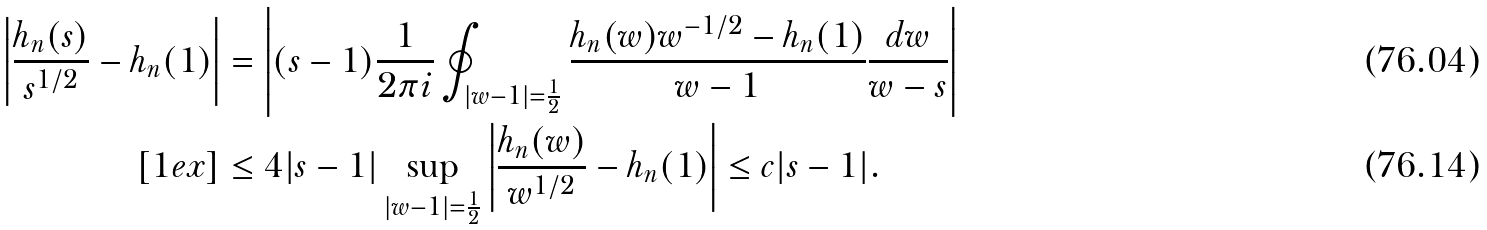<formula> <loc_0><loc_0><loc_500><loc_500>\left | \frac { h _ { n } ( s ) } { s ^ { 1 / 2 } } - h _ { n } ( 1 ) \right | & = \left | ( s - 1 ) \frac { 1 } { 2 \pi i } \oint _ { | w - 1 | = \frac { 1 } { 2 } } \frac { h _ { n } ( w ) w ^ { - 1 / 2 } - h _ { n } ( 1 ) } { w - 1 } \frac { d w } { w - s } \right | \\ [ 1 e x ] & \leq 4 | s - 1 | \sup _ { | w - 1 | = \frac { 1 } { 2 } } \left | \frac { h _ { n } ( w ) } { w ^ { 1 / 2 } } - h _ { n } ( 1 ) \right | \leq c | s - 1 | .</formula> 